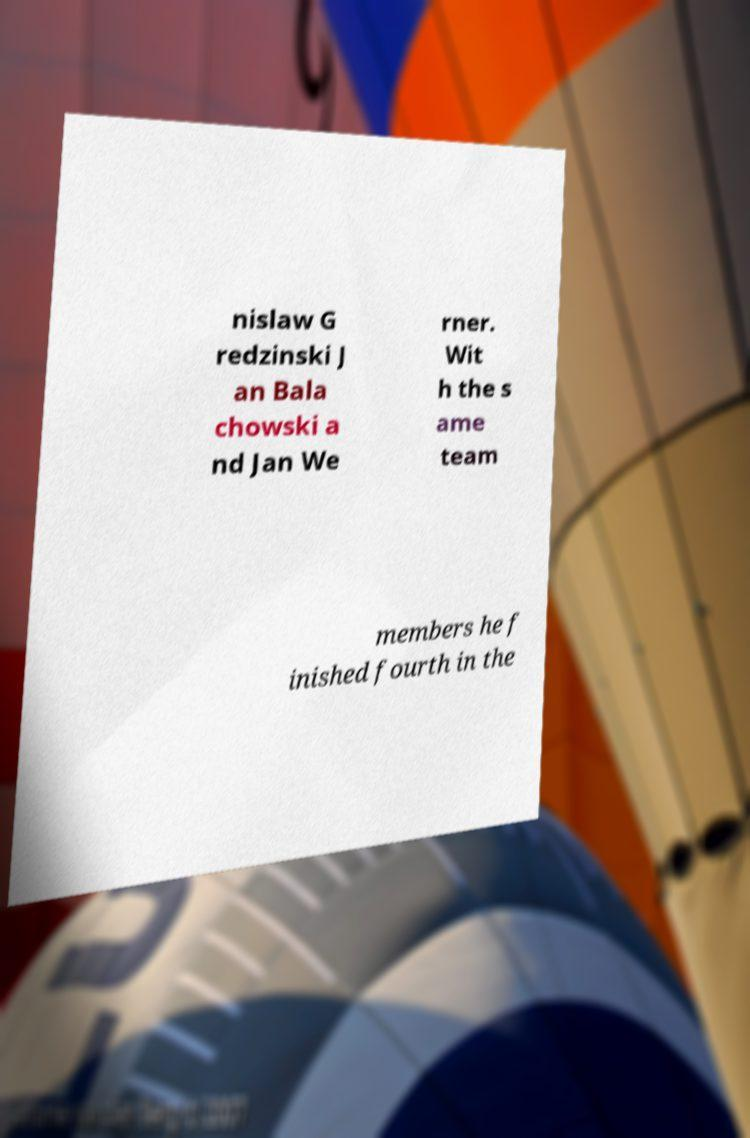Please read and relay the text visible in this image. What does it say? nislaw G redzinski J an Bala chowski a nd Jan We rner. Wit h the s ame team members he f inished fourth in the 